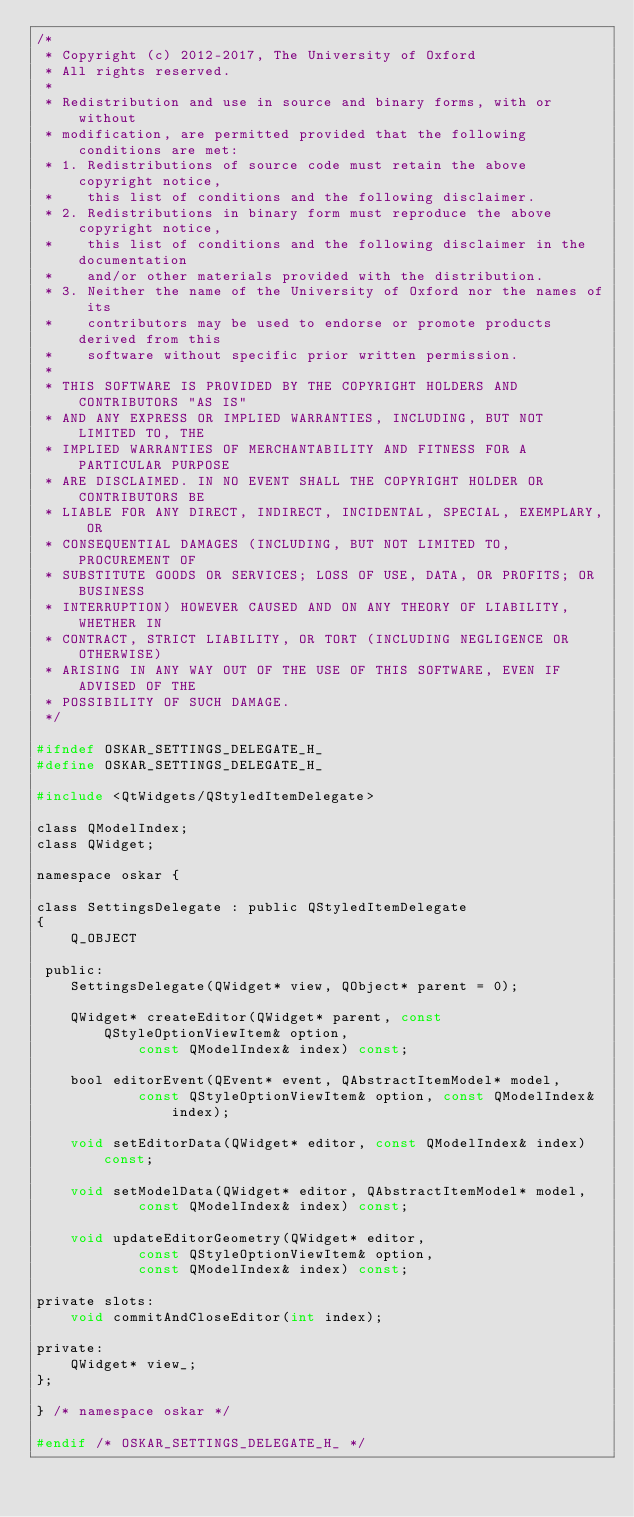Convert code to text. <code><loc_0><loc_0><loc_500><loc_500><_C_>/*
 * Copyright (c) 2012-2017, The University of Oxford
 * All rights reserved.
 *
 * Redistribution and use in source and binary forms, with or without
 * modification, are permitted provided that the following conditions are met:
 * 1. Redistributions of source code must retain the above copyright notice,
 *    this list of conditions and the following disclaimer.
 * 2. Redistributions in binary form must reproduce the above copyright notice,
 *    this list of conditions and the following disclaimer in the documentation
 *    and/or other materials provided with the distribution.
 * 3. Neither the name of the University of Oxford nor the names of its
 *    contributors may be used to endorse or promote products derived from this
 *    software without specific prior written permission.
 *
 * THIS SOFTWARE IS PROVIDED BY THE COPYRIGHT HOLDERS AND CONTRIBUTORS "AS IS"
 * AND ANY EXPRESS OR IMPLIED WARRANTIES, INCLUDING, BUT NOT LIMITED TO, THE
 * IMPLIED WARRANTIES OF MERCHANTABILITY AND FITNESS FOR A PARTICULAR PURPOSE
 * ARE DISCLAIMED. IN NO EVENT SHALL THE COPYRIGHT HOLDER OR CONTRIBUTORS BE
 * LIABLE FOR ANY DIRECT, INDIRECT, INCIDENTAL, SPECIAL, EXEMPLARY, OR
 * CONSEQUENTIAL DAMAGES (INCLUDING, BUT NOT LIMITED TO, PROCUREMENT OF
 * SUBSTITUTE GOODS OR SERVICES; LOSS OF USE, DATA, OR PROFITS; OR BUSINESS
 * INTERRUPTION) HOWEVER CAUSED AND ON ANY THEORY OF LIABILITY, WHETHER IN
 * CONTRACT, STRICT LIABILITY, OR TORT (INCLUDING NEGLIGENCE OR OTHERWISE)
 * ARISING IN ANY WAY OUT OF THE USE OF THIS SOFTWARE, EVEN IF ADVISED OF THE
 * POSSIBILITY OF SUCH DAMAGE.
 */

#ifndef OSKAR_SETTINGS_DELEGATE_H_
#define OSKAR_SETTINGS_DELEGATE_H_

#include <QtWidgets/QStyledItemDelegate>

class QModelIndex;
class QWidget;

namespace oskar {

class SettingsDelegate : public QStyledItemDelegate
{
    Q_OBJECT

 public:
    SettingsDelegate(QWidget* view, QObject* parent = 0);

    QWidget* createEditor(QWidget* parent, const QStyleOptionViewItem& option,
            const QModelIndex& index) const;

    bool editorEvent(QEvent* event, QAbstractItemModel* model,
            const QStyleOptionViewItem& option, const QModelIndex& index);

    void setEditorData(QWidget* editor, const QModelIndex& index) const;

    void setModelData(QWidget* editor, QAbstractItemModel* model,
            const QModelIndex& index) const;

    void updateEditorGeometry(QWidget* editor,
            const QStyleOptionViewItem& option,
            const QModelIndex& index) const;

private slots:
    void commitAndCloseEditor(int index);

private:
    QWidget* view_;
};

} /* namespace oskar */

#endif /* OSKAR_SETTINGS_DELEGATE_H_ */
</code> 